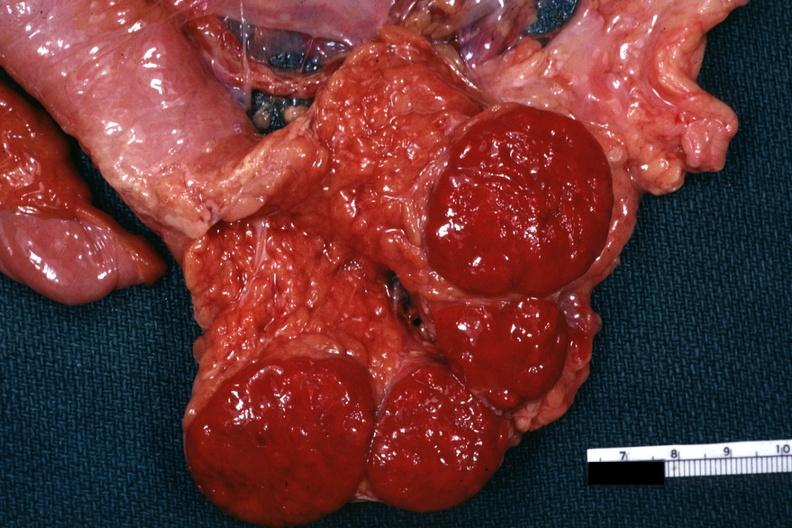does cortical nodule show tail of pancreas with spleens?
Answer the question using a single word or phrase. No 